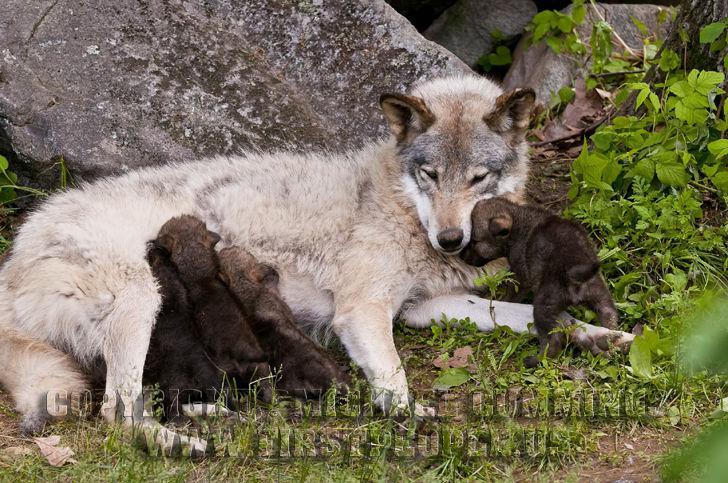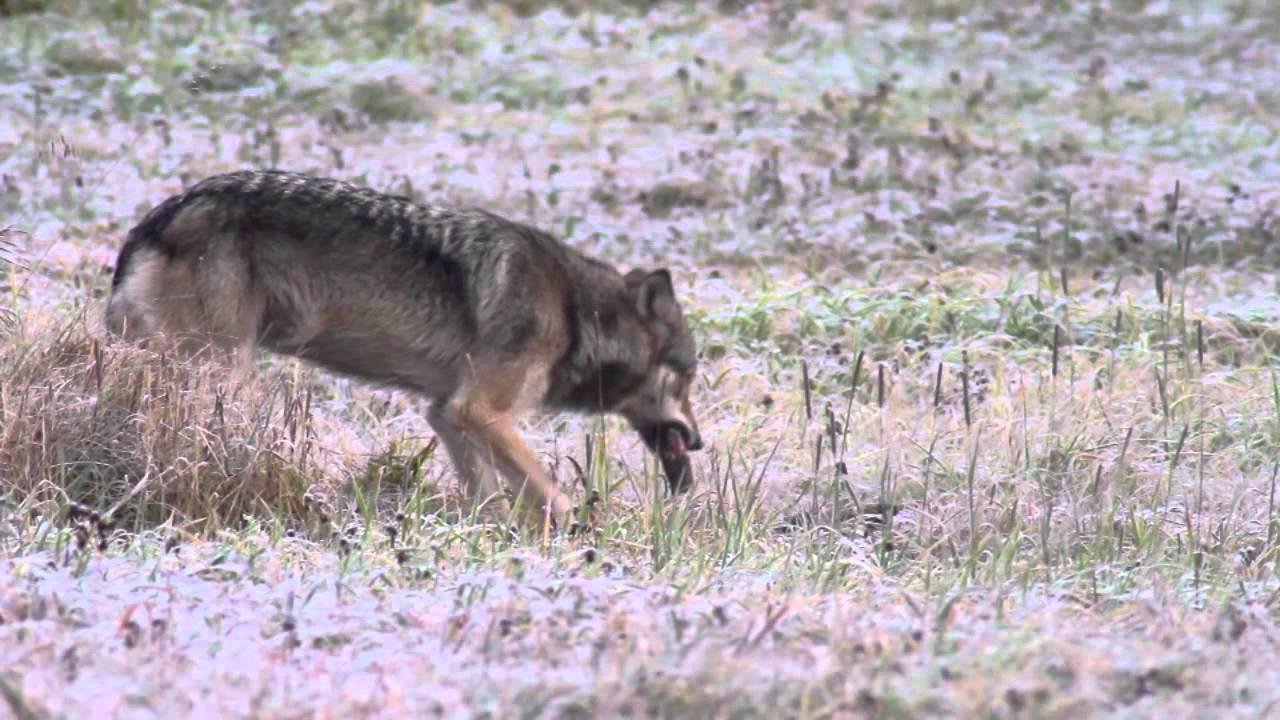The first image is the image on the left, the second image is the image on the right. Evaluate the accuracy of this statement regarding the images: "The wild dogs in the image on the right are feeding on their prey.". Is it true? Answer yes or no. No. The first image is the image on the left, the second image is the image on the right. Evaluate the accuracy of this statement regarding the images: "Two or more wolves are eating an animal carcass together.". Is it true? Answer yes or no. No. 